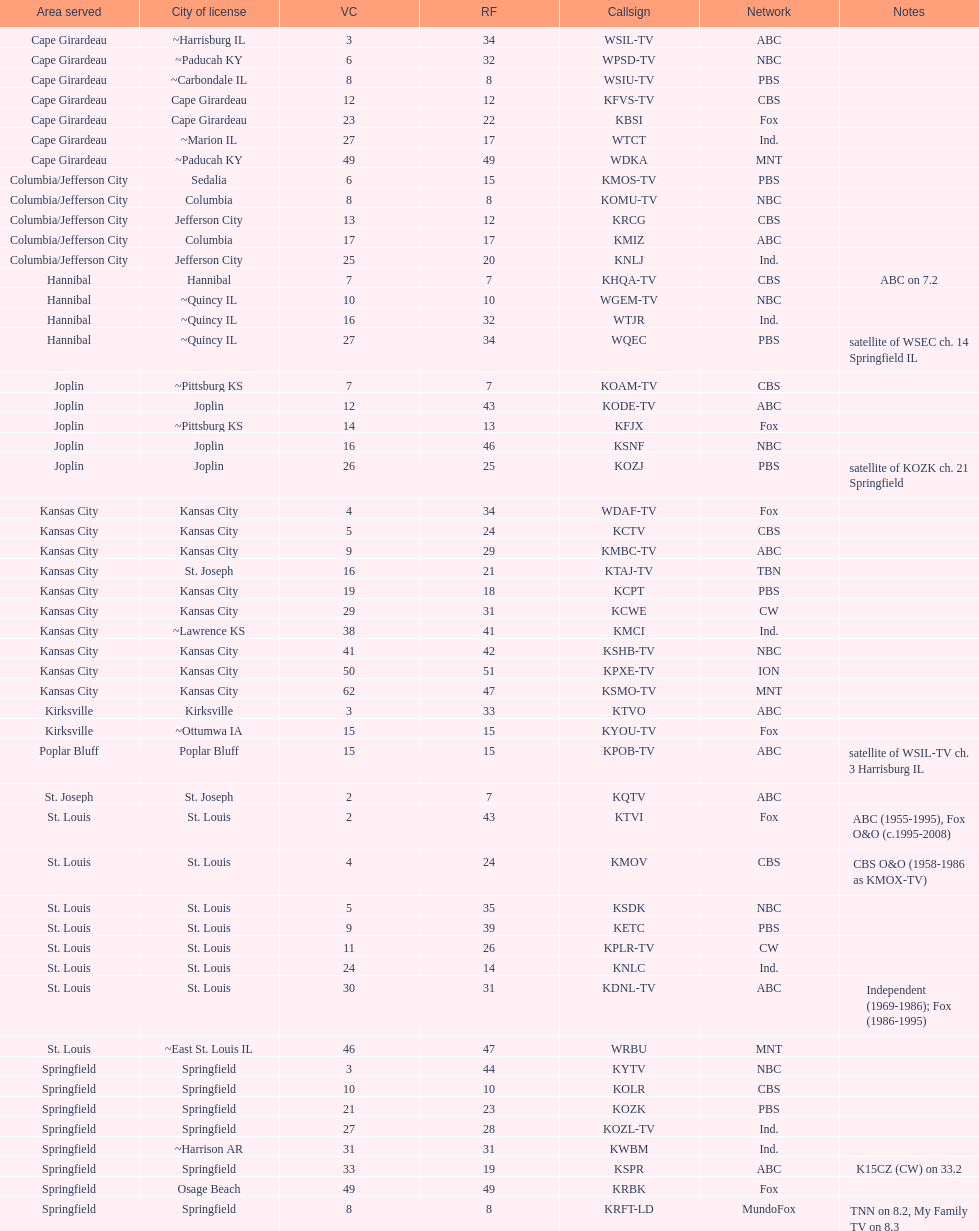What is the aggregate amount of stations providing service in the cape girardeau area? 7. 